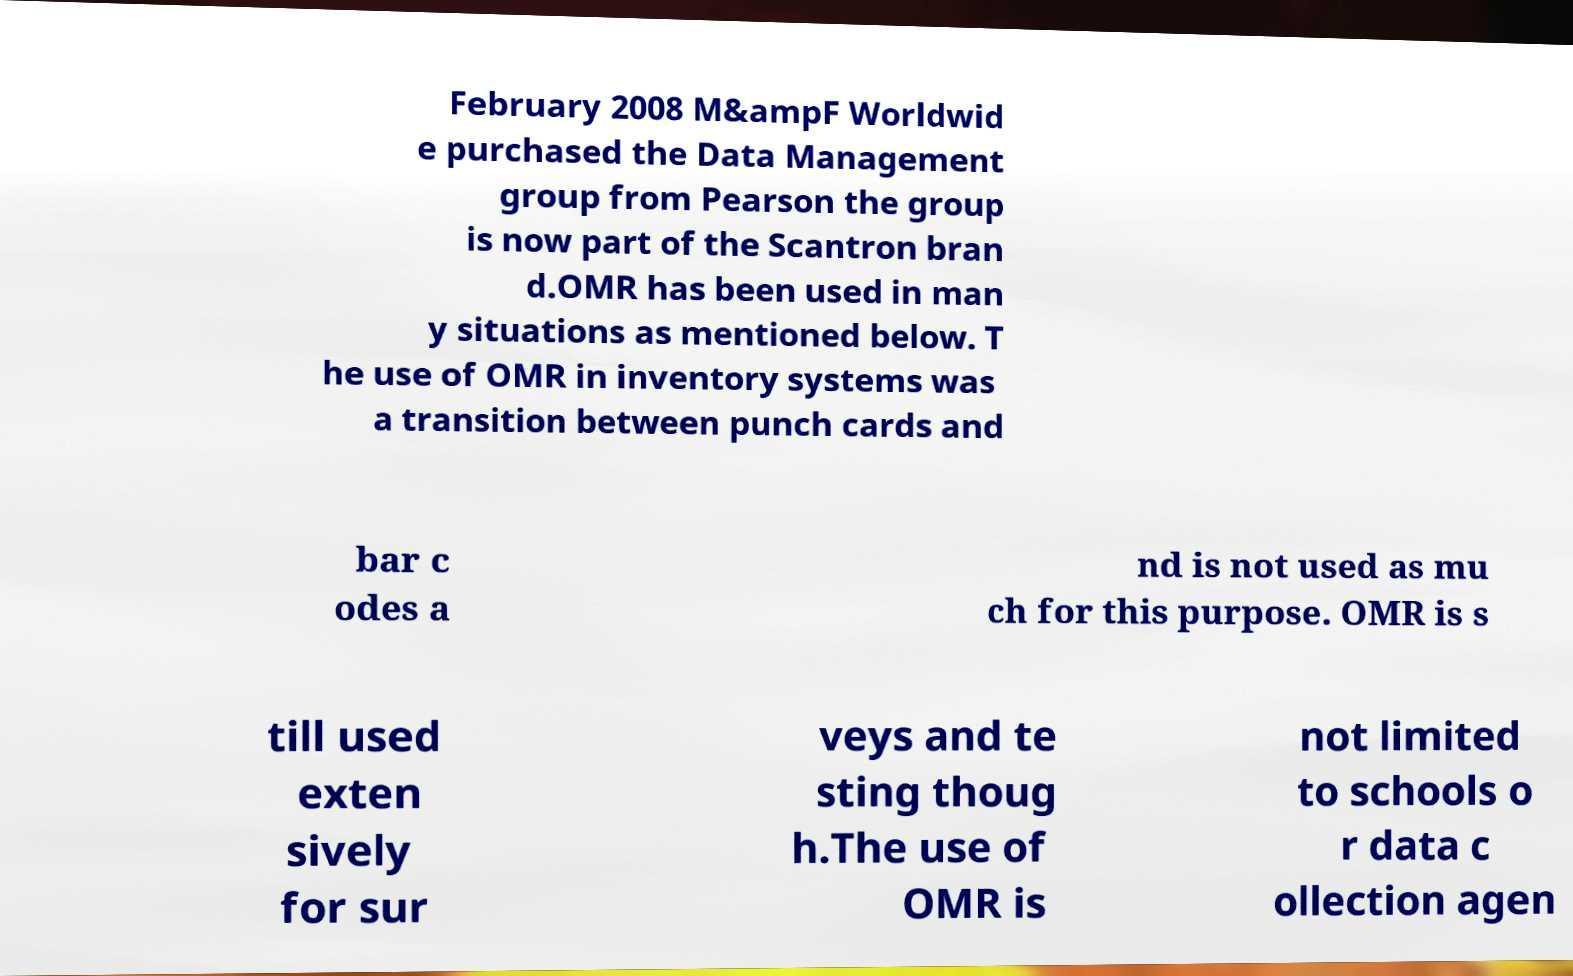I need the written content from this picture converted into text. Can you do that? February 2008 M&ampF Worldwid e purchased the Data Management group from Pearson the group is now part of the Scantron bran d.OMR has been used in man y situations as mentioned below. T he use of OMR in inventory systems was a transition between punch cards and bar c odes a nd is not used as mu ch for this purpose. OMR is s till used exten sively for sur veys and te sting thoug h.The use of OMR is not limited to schools o r data c ollection agen 